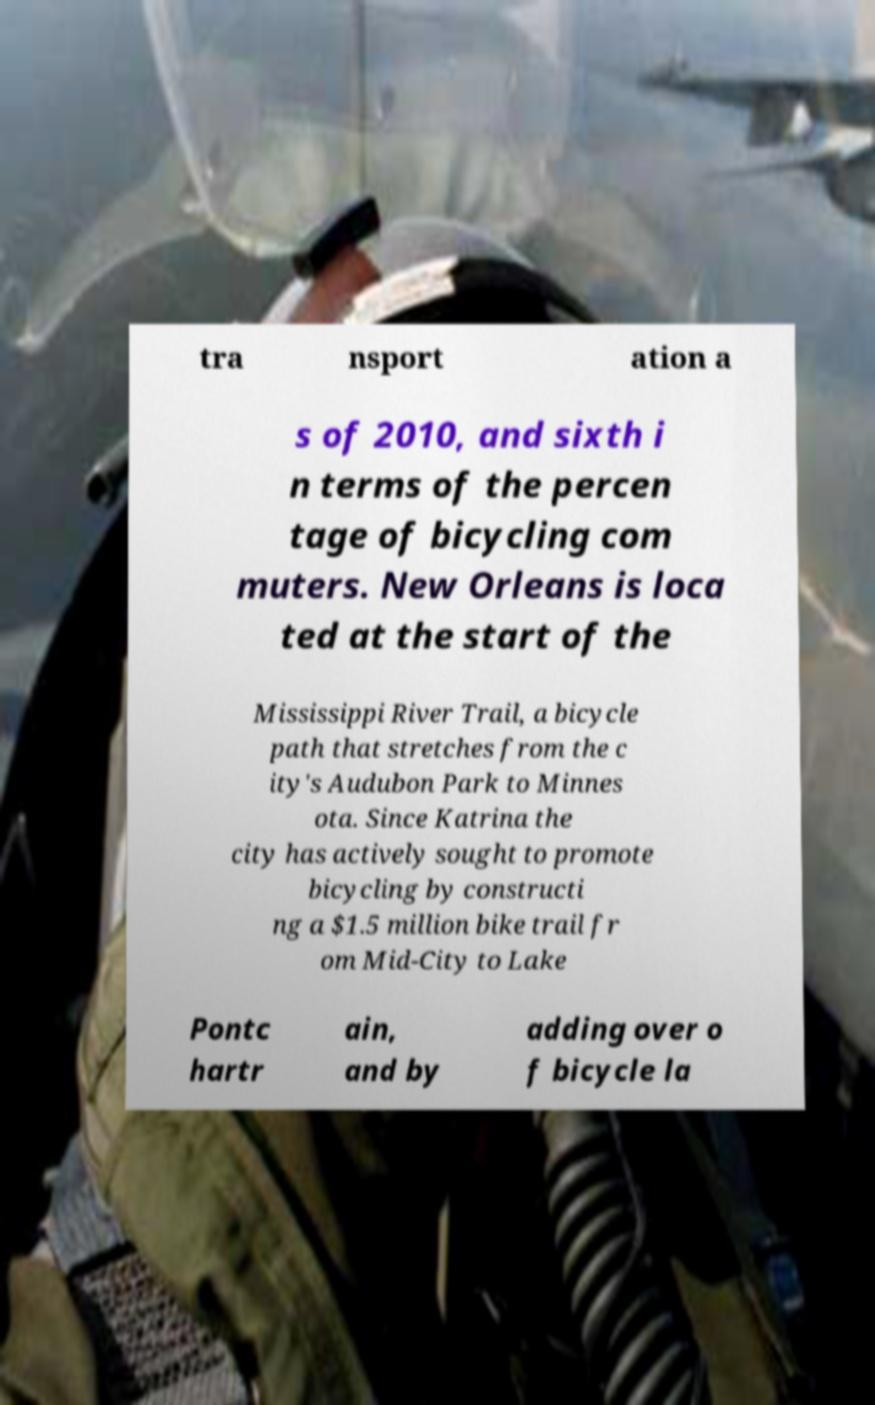What messages or text are displayed in this image? I need them in a readable, typed format. tra nsport ation a s of 2010, and sixth i n terms of the percen tage of bicycling com muters. New Orleans is loca ted at the start of the Mississippi River Trail, a bicycle path that stretches from the c ity's Audubon Park to Minnes ota. Since Katrina the city has actively sought to promote bicycling by constructi ng a $1.5 million bike trail fr om Mid-City to Lake Pontc hartr ain, and by adding over o f bicycle la 